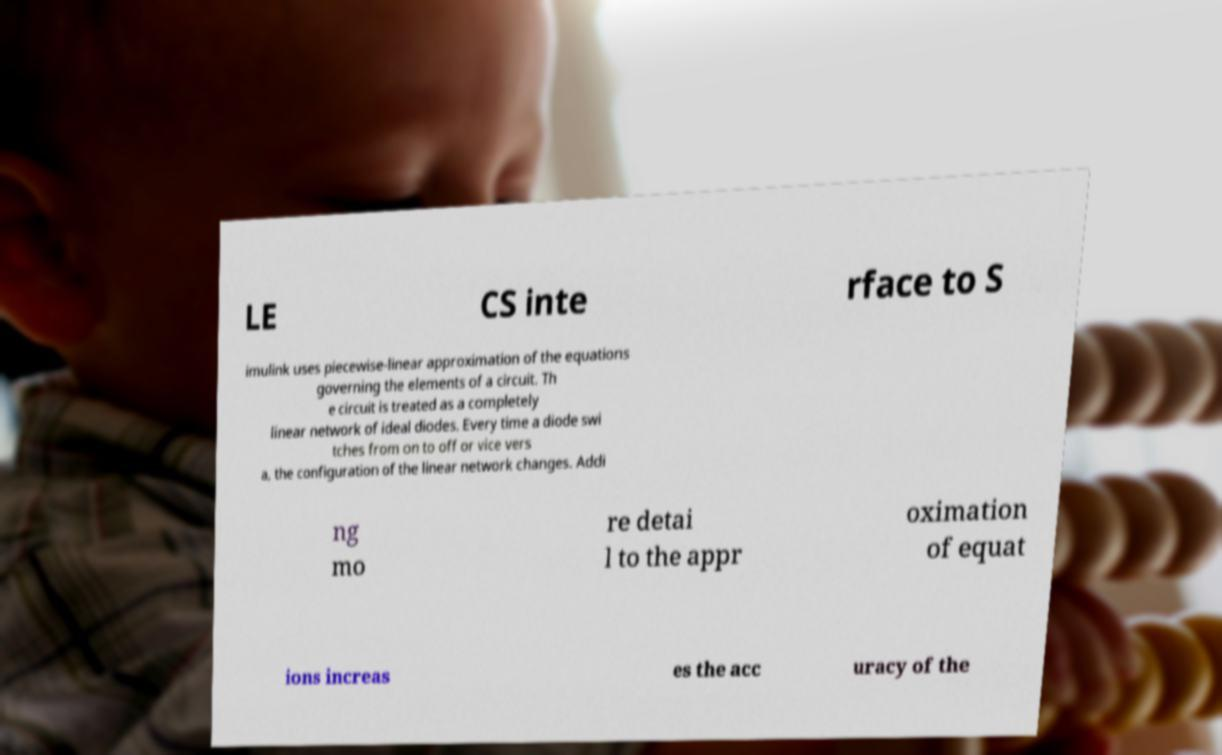I need the written content from this picture converted into text. Can you do that? LE CS inte rface to S imulink uses piecewise-linear approximation of the equations governing the elements of a circuit. Th e circuit is treated as a completely linear network of ideal diodes. Every time a diode swi tches from on to off or vice vers a, the configuration of the linear network changes. Addi ng mo re detai l to the appr oximation of equat ions increas es the acc uracy of the 